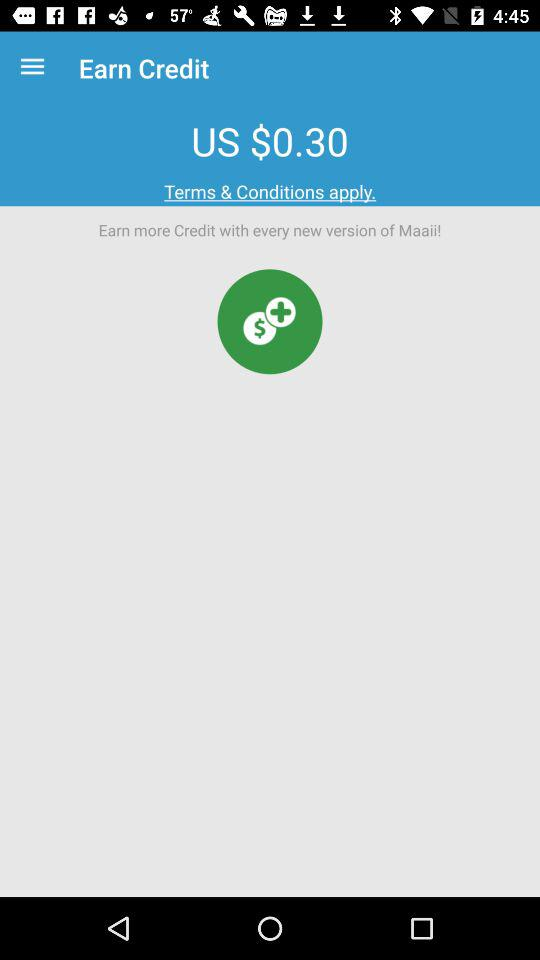How much is the balance? The balance is US $0.30. 